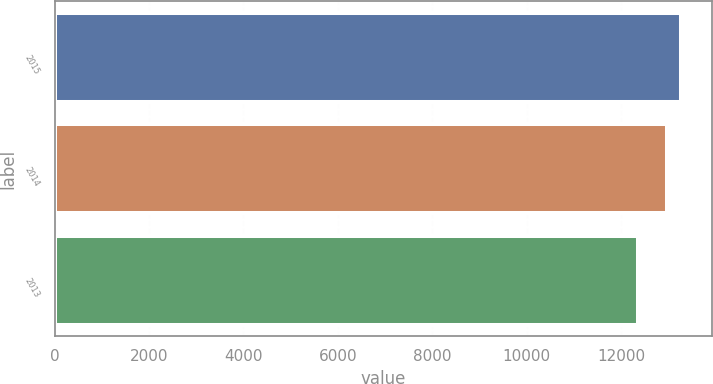Convert chart. <chart><loc_0><loc_0><loc_500><loc_500><bar_chart><fcel>2015<fcel>2014<fcel>2013<nl><fcel>13266<fcel>12962<fcel>12353<nl></chart> 